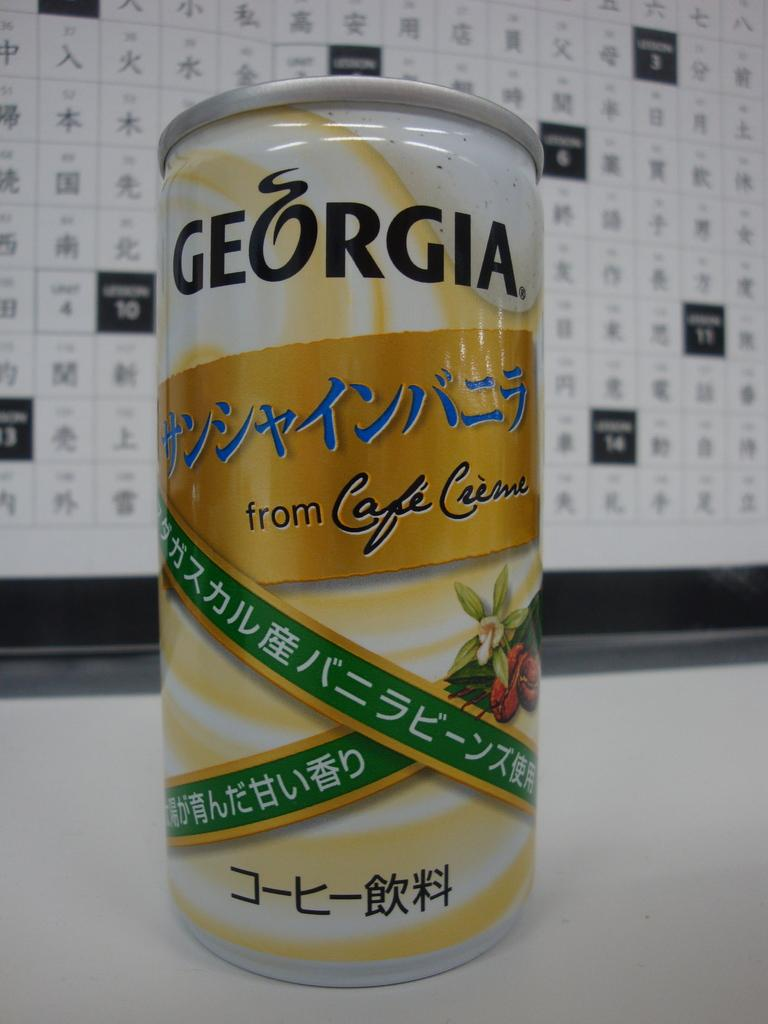<image>
Summarize the visual content of the image. The tin of drink shown is called Georgia. 